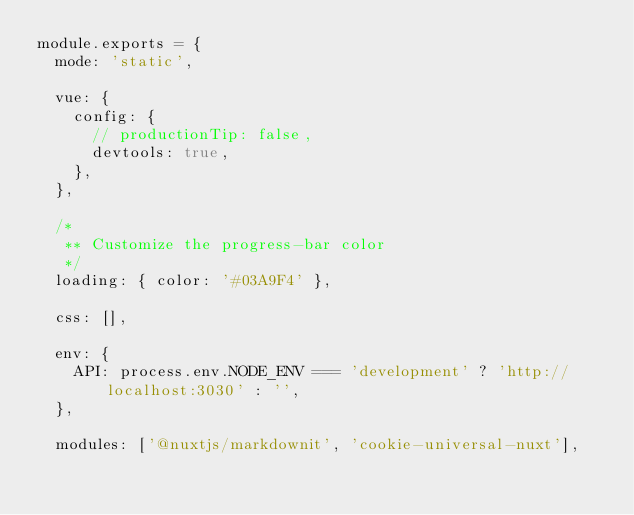Convert code to text. <code><loc_0><loc_0><loc_500><loc_500><_JavaScript_>module.exports = {
  mode: 'static',

  vue: {
    config: {
      // productionTip: false,
      devtools: true,
    },
  },

  /*
   ** Customize the progress-bar color
   */
  loading: { color: '#03A9F4' },

  css: [],

  env: {
    API: process.env.NODE_ENV === 'development' ? 'http://localhost:3030' : '',
  },

  modules: ['@nuxtjs/markdownit', 'cookie-universal-nuxt'],</code> 